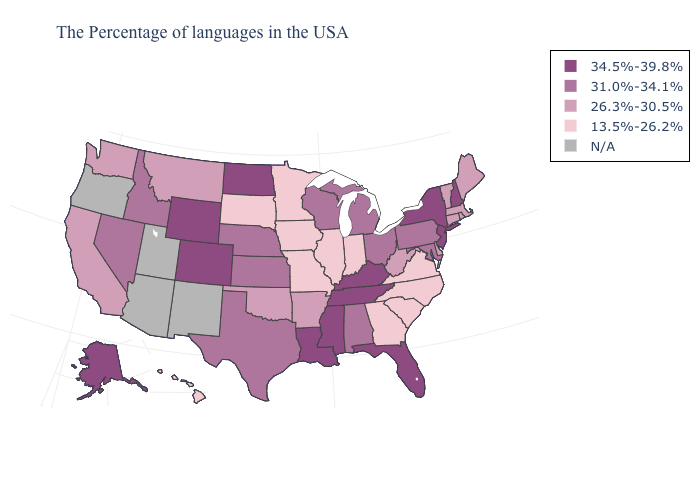What is the lowest value in states that border Washington?
Quick response, please. 31.0%-34.1%. What is the value of Virginia?
Write a very short answer. 13.5%-26.2%. Does the first symbol in the legend represent the smallest category?
Answer briefly. No. What is the lowest value in the USA?
Give a very brief answer. 13.5%-26.2%. Does Wyoming have the lowest value in the West?
Keep it brief. No. Name the states that have a value in the range 31.0%-34.1%?
Give a very brief answer. Maryland, Pennsylvania, Ohio, Michigan, Alabama, Wisconsin, Kansas, Nebraska, Texas, Idaho, Nevada. What is the value of Kentucky?
Give a very brief answer. 34.5%-39.8%. Among the states that border Florida , does Georgia have the lowest value?
Keep it brief. Yes. What is the highest value in the USA?
Write a very short answer. 34.5%-39.8%. Name the states that have a value in the range 26.3%-30.5%?
Quick response, please. Maine, Massachusetts, Rhode Island, Vermont, Connecticut, Delaware, West Virginia, Arkansas, Oklahoma, Montana, California, Washington. What is the value of Ohio?
Keep it brief. 31.0%-34.1%. Which states have the lowest value in the Northeast?
Keep it brief. Maine, Massachusetts, Rhode Island, Vermont, Connecticut. Name the states that have a value in the range 31.0%-34.1%?
Be succinct. Maryland, Pennsylvania, Ohio, Michigan, Alabama, Wisconsin, Kansas, Nebraska, Texas, Idaho, Nevada. What is the lowest value in the MidWest?
Quick response, please. 13.5%-26.2%. Among the states that border Minnesota , which have the lowest value?
Short answer required. Iowa, South Dakota. 